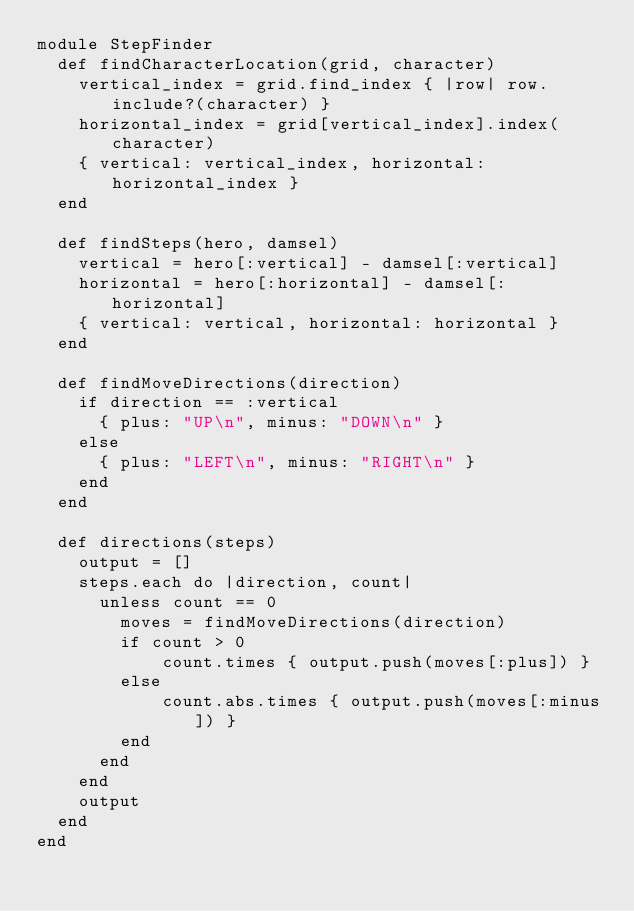<code> <loc_0><loc_0><loc_500><loc_500><_Ruby_>module StepFinder
  def findCharacterLocation(grid, character)
    vertical_index = grid.find_index { |row| row.include?(character) }
    horizontal_index = grid[vertical_index].index(character)
    { vertical: vertical_index, horizontal: horizontal_index }
  end

  def findSteps(hero, damsel)
    vertical = hero[:vertical] - damsel[:vertical]
    horizontal = hero[:horizontal] - damsel[:horizontal]
    { vertical: vertical, horizontal: horizontal }
  end

  def findMoveDirections(direction)
    if direction == :vertical
      { plus: "UP\n", minus: "DOWN\n" }
    else
      { plus: "LEFT\n", minus: "RIGHT\n" }
    end
  end

  def directions(steps)
    output = []
    steps.each do |direction, count|
      unless count == 0
        moves = findMoveDirections(direction)
        if count > 0
            count.times { output.push(moves[:plus]) }
        else
            count.abs.times { output.push(moves[:minus]) }
        end
      end
    end
    output
  end
end
</code> 